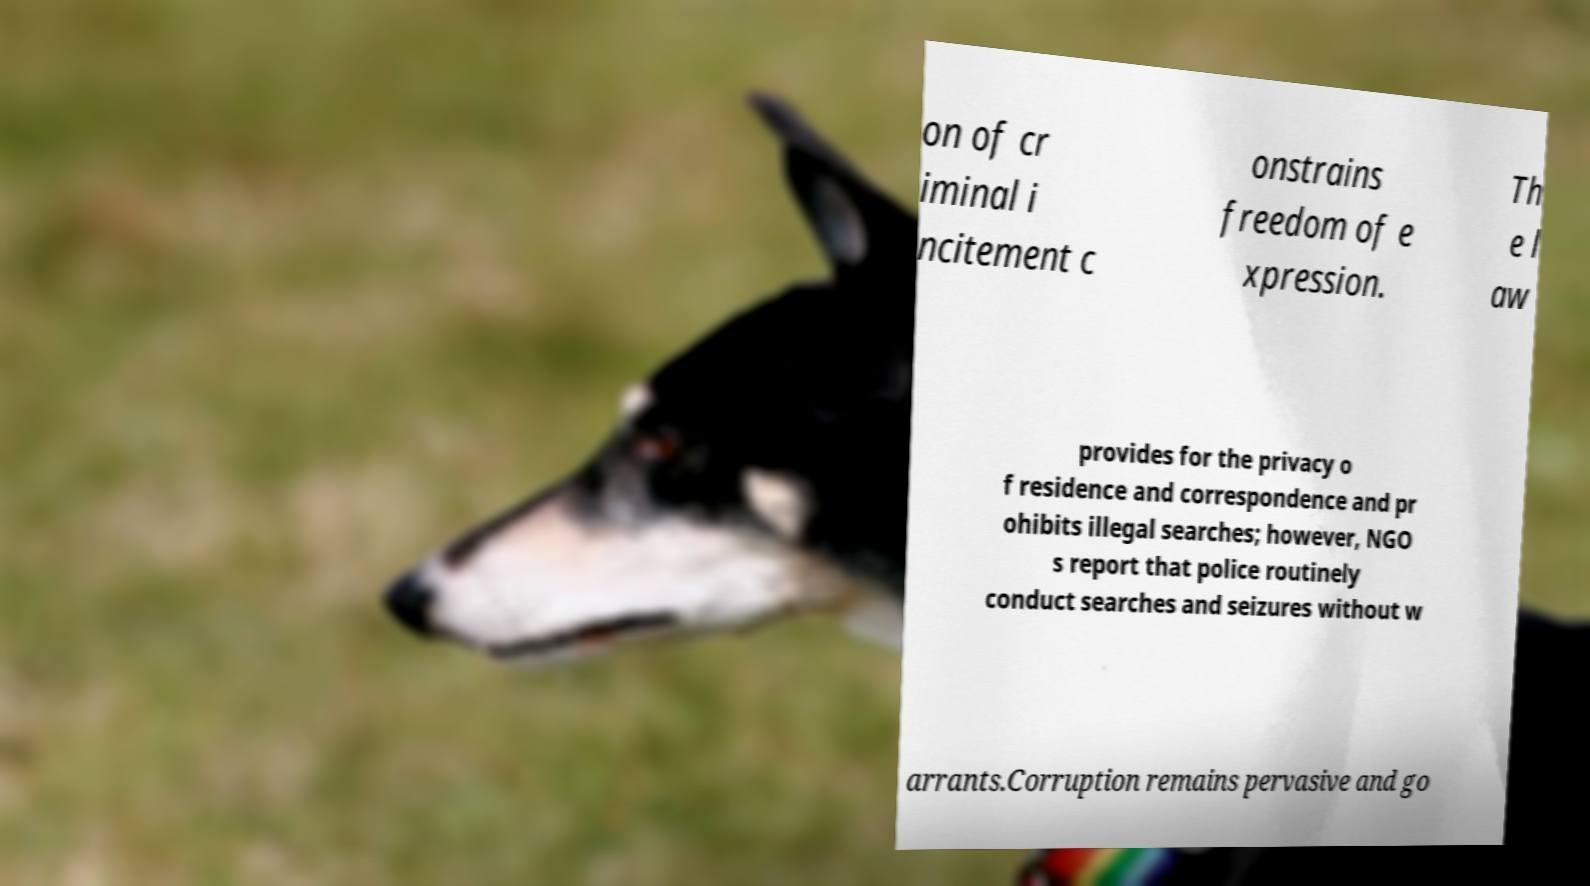Can you accurately transcribe the text from the provided image for me? on of cr iminal i ncitement c onstrains freedom of e xpression. Th e l aw provides for the privacy o f residence and correspondence and pr ohibits illegal searches; however, NGO s report that police routinely conduct searches and seizures without w arrants.Corruption remains pervasive and go 